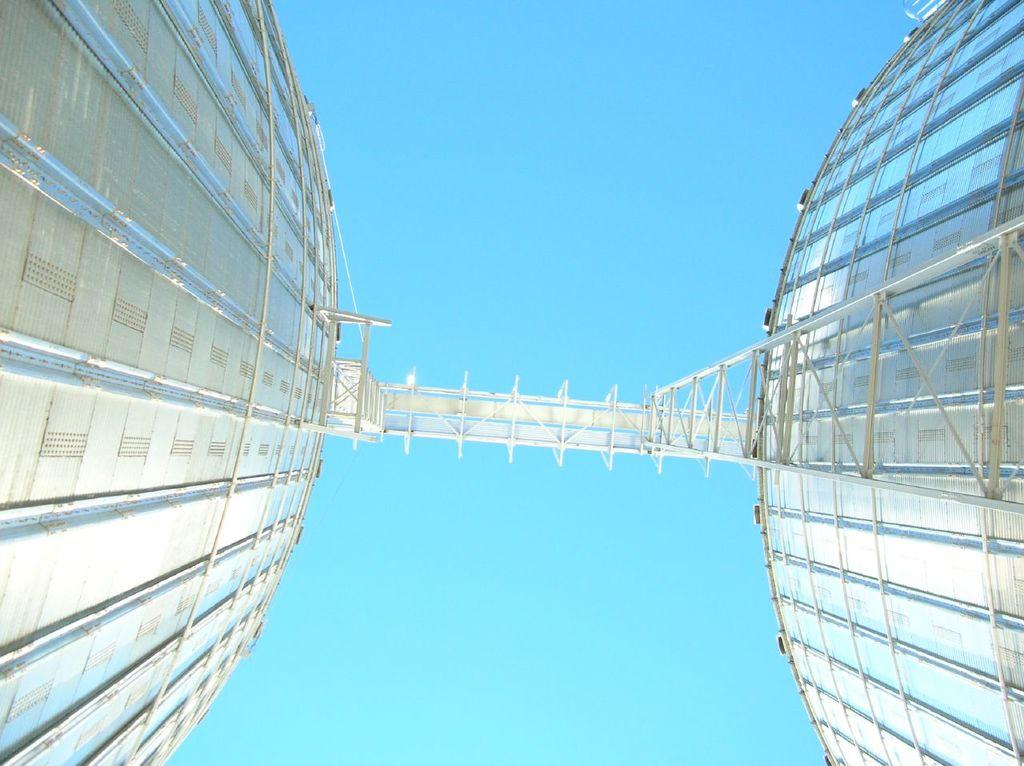What type of structures are present in the image? There are metal towers in the image. Is there any connection between the towers? Yes, there is a bridge between the towers. What can be seen in the background of the image? The sky is visible behind the towers. Can you see a flock of pigs crossing the bridge in the image? No, there are no pigs or any animals visible in the image. Is there a kissing couple on the bridge in the image? No, there are no people or any indication of a kissing couple in the image. 